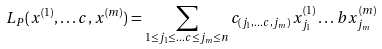Convert formula to latex. <formula><loc_0><loc_0><loc_500><loc_500>L _ { P } ( x ^ { ( 1 ) } , \dots c , x ^ { ( m ) } ) = \sum _ { 1 \leq j _ { 1 } \leq \dots c \leq j _ { m } \leq n } c _ { ( j _ { 1 } , \dots c , j _ { m } ) } \, x ^ { ( 1 ) } _ { j _ { 1 } } \dots b x ^ { ( m ) } _ { j _ { m } }</formula> 